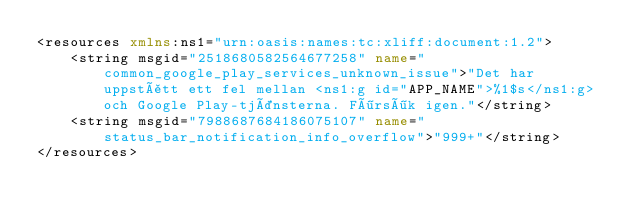Convert code to text. <code><loc_0><loc_0><loc_500><loc_500><_XML_><resources xmlns:ns1="urn:oasis:names:tc:xliff:document:1.2">
    <string msgid="2518680582564677258" name="common_google_play_services_unknown_issue">"Det har uppstått ett fel mellan <ns1:g id="APP_NAME">%1$s</ns1:g> och Google Play-tjänsterna. Försök igen."</string>
    <string msgid="7988687684186075107" name="status_bar_notification_info_overflow">"999+"</string>
</resources></code> 